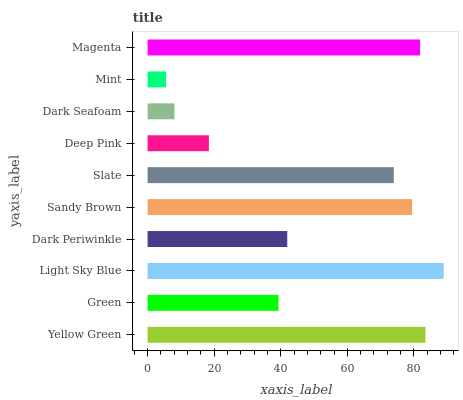Is Mint the minimum?
Answer yes or no. Yes. Is Light Sky Blue the maximum?
Answer yes or no. Yes. Is Green the minimum?
Answer yes or no. No. Is Green the maximum?
Answer yes or no. No. Is Yellow Green greater than Green?
Answer yes or no. Yes. Is Green less than Yellow Green?
Answer yes or no. Yes. Is Green greater than Yellow Green?
Answer yes or no. No. Is Yellow Green less than Green?
Answer yes or no. No. Is Slate the high median?
Answer yes or no. Yes. Is Dark Periwinkle the low median?
Answer yes or no. Yes. Is Light Sky Blue the high median?
Answer yes or no. No. Is Dark Seafoam the low median?
Answer yes or no. No. 